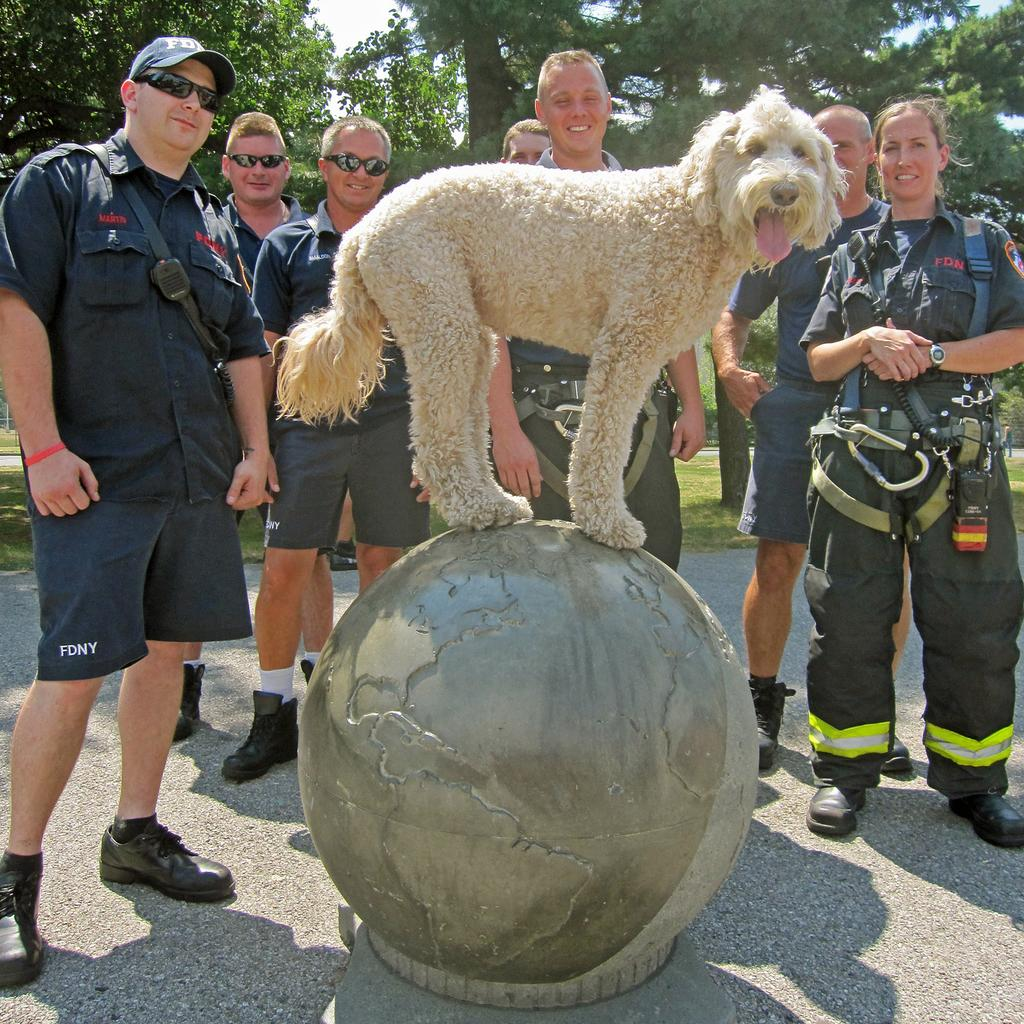How many people are in the image? There is a group of persons in the image, but no specific number is mentioned, so we cannot determine the exact number. What other living creature is present in the image? There is a dog in the image. What can be seen in the background of the image? There are trees and the sky visible in the background of the image. What type of pan is being used to cook the flock in the image? There is no flock or pan present in the image, so this question cannot be answered. 